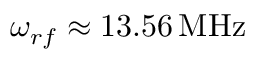Convert formula to latex. <formula><loc_0><loc_0><loc_500><loc_500>\omega _ { r f } \approx 1 3 . 5 6 \, M H z</formula> 